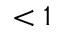<formula> <loc_0><loc_0><loc_500><loc_500>< 1</formula> 